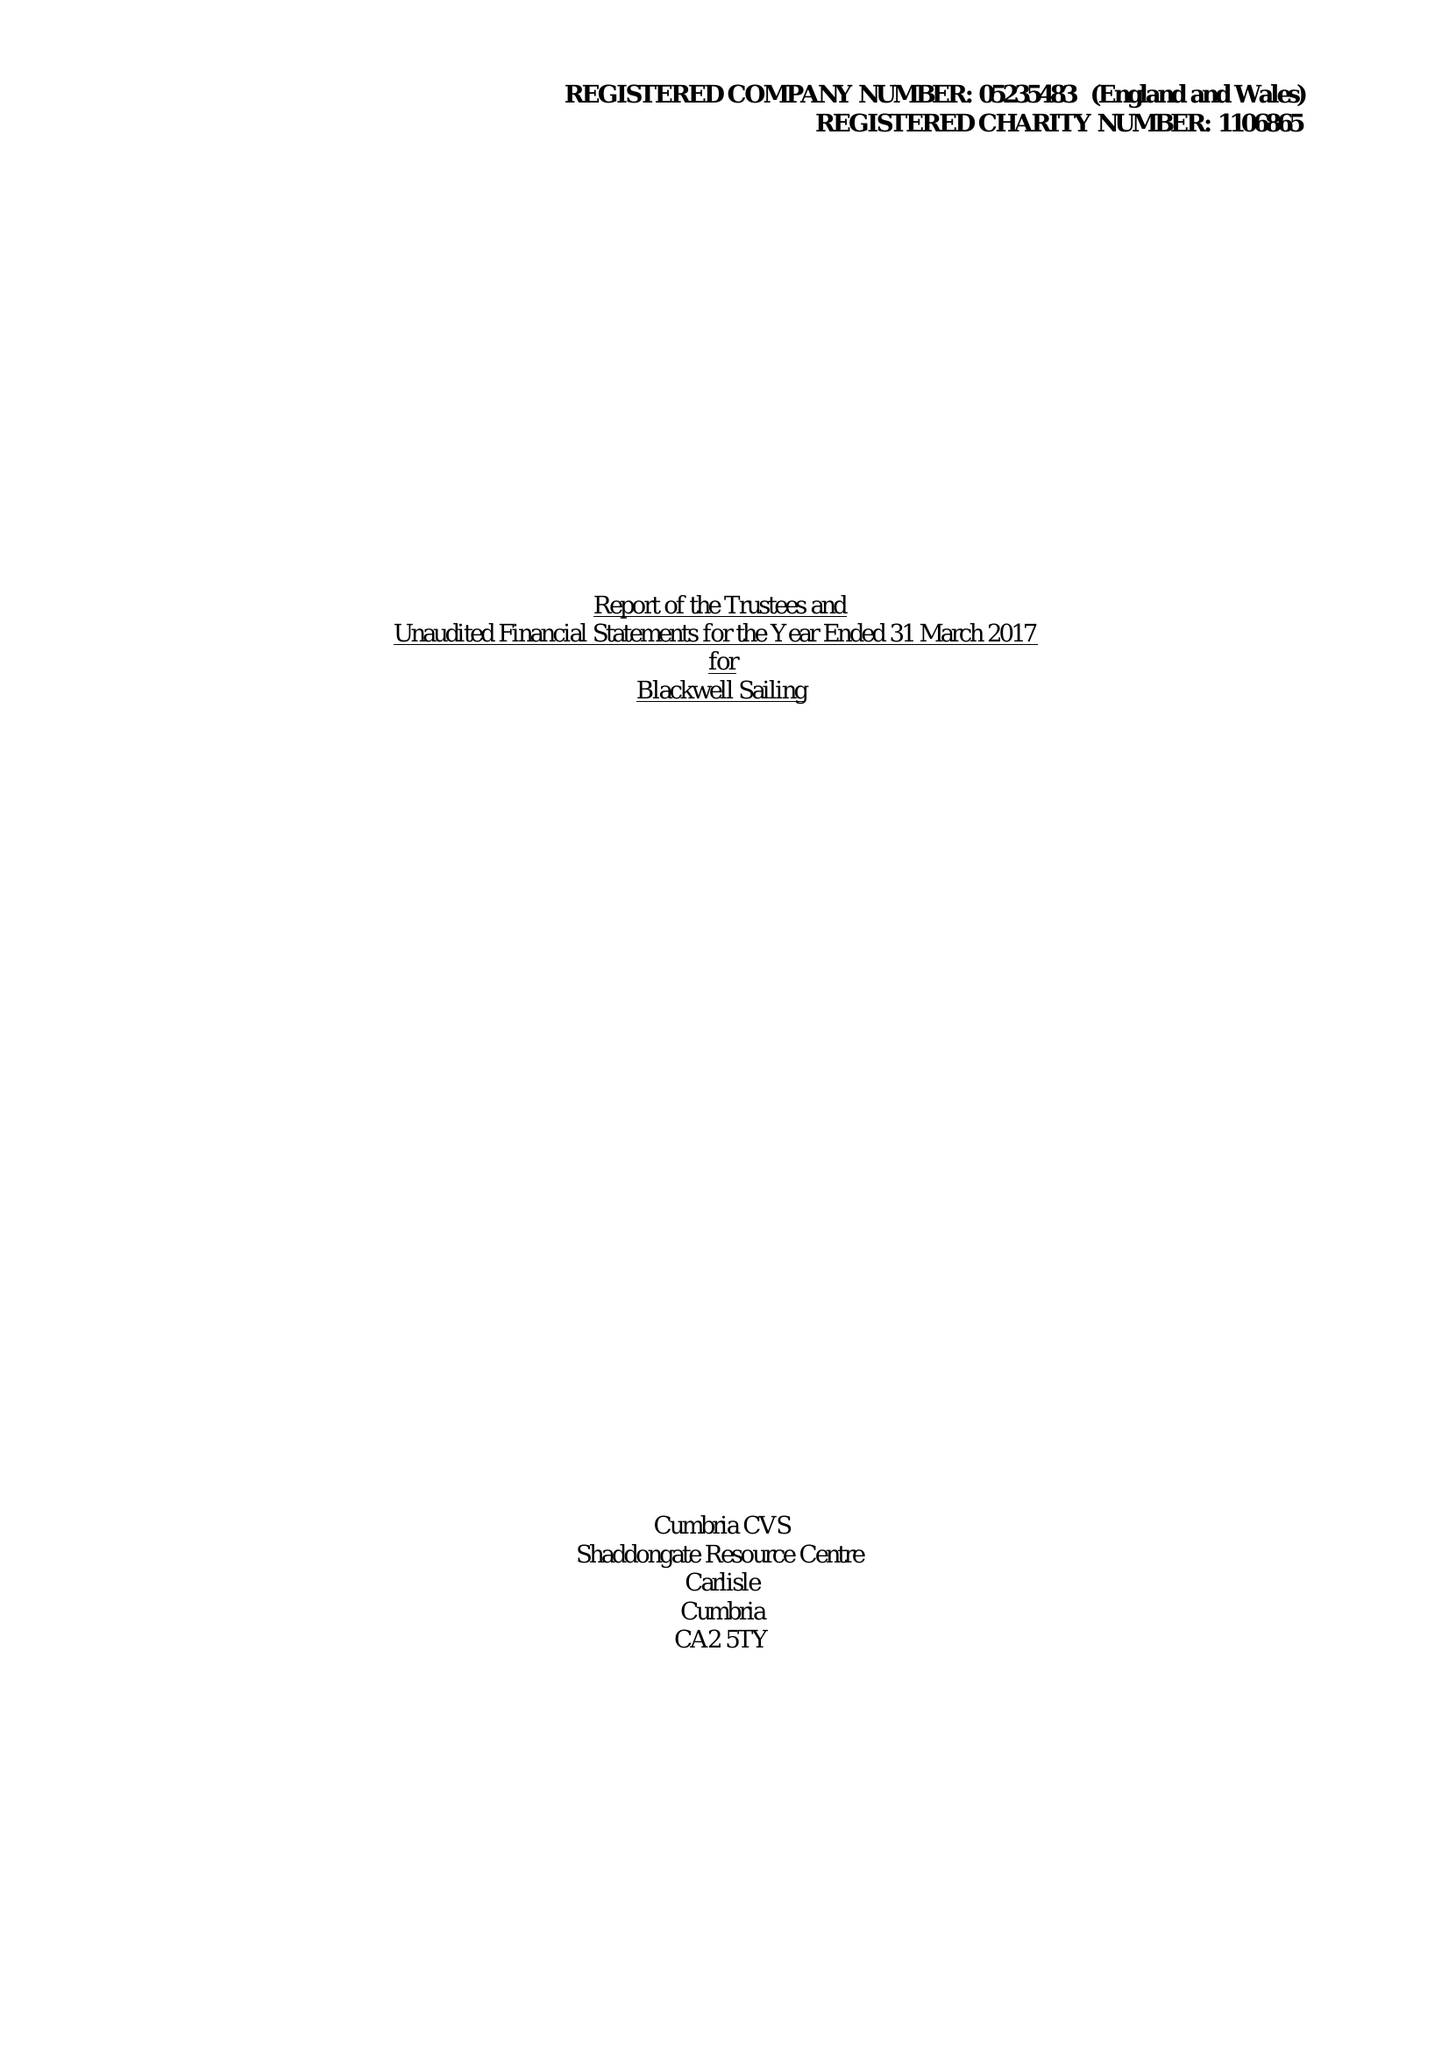What is the value for the address__post_town?
Answer the question using a single word or phrase. WINDERMERE 